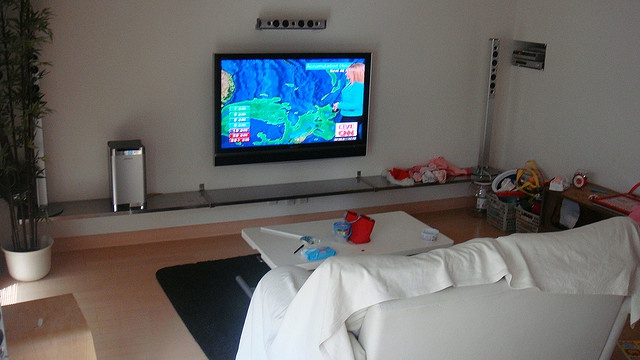Describe the objects in this image and their specific colors. I can see couch in black, darkgray, lightgray, and gray tones, tv in black, blue, cyan, and lightblue tones, and potted plant in black and gray tones in this image. 